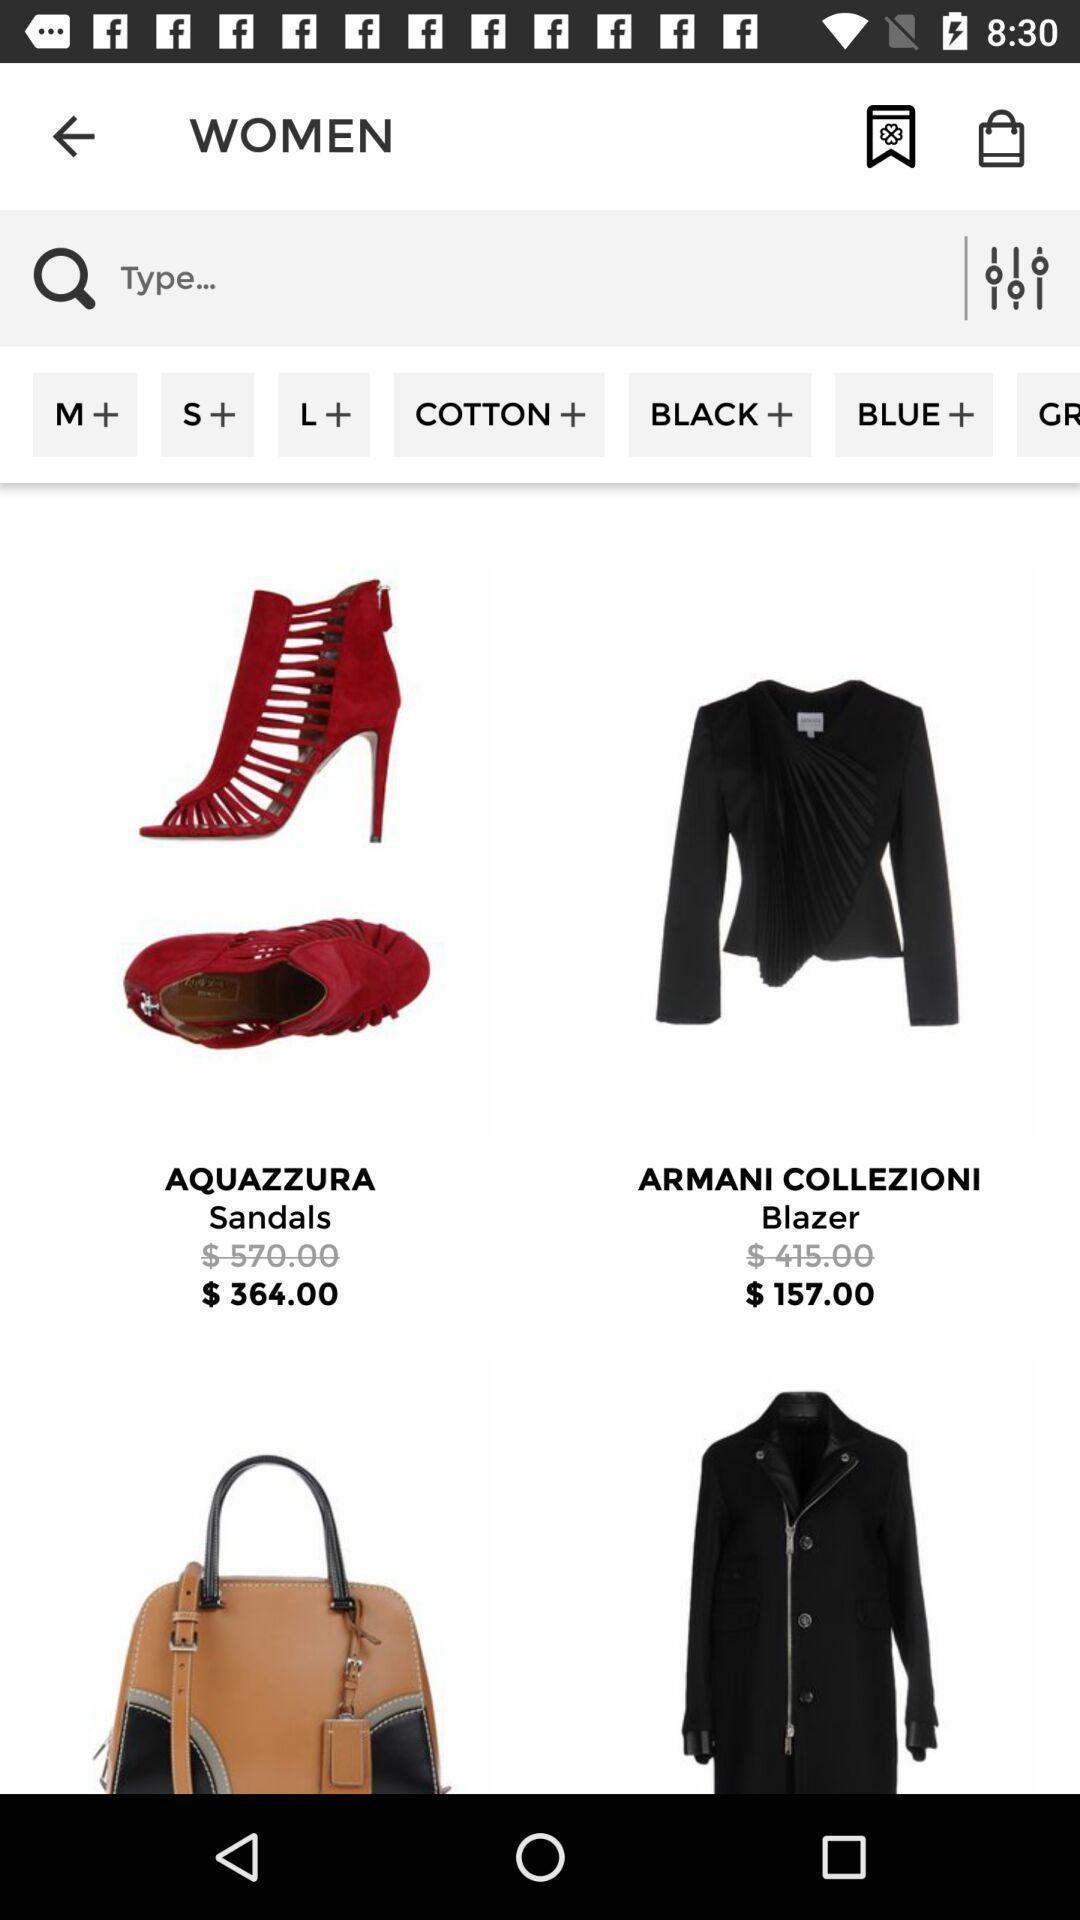What can you discern from this picture? Page featuring multiple products. 